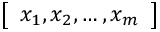Convert formula to latex. <formula><loc_0><loc_0><loc_500><loc_500>\left [ \begin{array} { l } { x _ { 1 } , x _ { 2 } , \dots , x _ { m } } \end{array} \right ]</formula> 